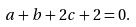Convert formula to latex. <formula><loc_0><loc_0><loc_500><loc_500>a + b + 2 c + 2 = 0 .</formula> 